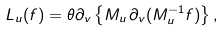Convert formula to latex. <formula><loc_0><loc_0><loc_500><loc_500>L _ { u } ( f ) = \theta \partial _ { v } \left \{ M _ { u } \, \partial _ { v } ( M _ { u } ^ { - 1 } f ) \right \} ,</formula> 